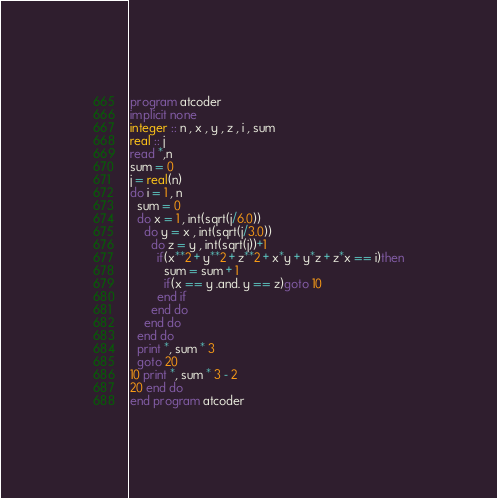Convert code to text. <code><loc_0><loc_0><loc_500><loc_500><_FORTRAN_>program atcoder
implicit none
integer :: n , x , y , z , i , sum
real :: j
read *,n
sum = 0
j = real(n)
do i = 1 , n
  sum = 0
  do x = 1 , int(sqrt(j/6.0))
    do y = x , int(sqrt(j/3.0))
      do z = y , int(sqrt(j))+1
        if(x**2 + y**2 + z**2 + x*y + y*z + z*x == i)then
          sum = sum + 1
          if(x == y .and. y == z)goto 10
        end if
      end do
    end do
  end do
  print *, sum * 3
  goto 20
10 print *, sum * 3 - 2
20 end do
end program atcoder
</code> 